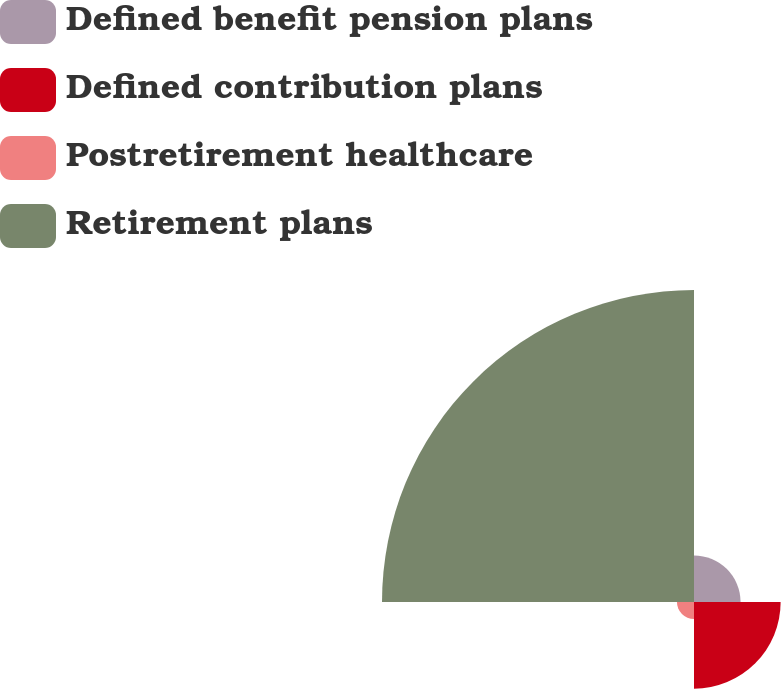Convert chart. <chart><loc_0><loc_0><loc_500><loc_500><pie_chart><fcel>Defined benefit pension plans<fcel>Defined contribution plans<fcel>Postretirement healthcare<fcel>Retirement plans<nl><fcel>10.07%<fcel>18.74%<fcel>3.69%<fcel>67.49%<nl></chart> 